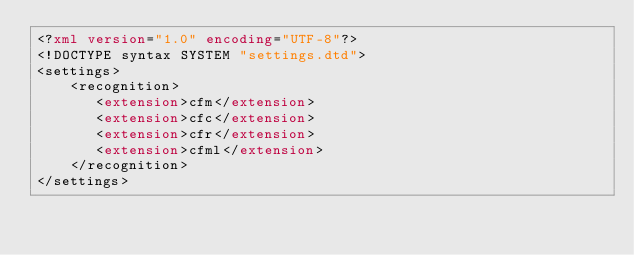<code> <loc_0><loc_0><loc_500><loc_500><_XML_><?xml version="1.0" encoding="UTF-8"?>
<!DOCTYPE syntax SYSTEM "settings.dtd">
<settings>
    <recognition>
	   <extension>cfm</extension>
	   <extension>cfc</extension>
	   <extension>cfr</extension>
	   <extension>cfml</extension>
    </recognition>
</settings>


</code> 